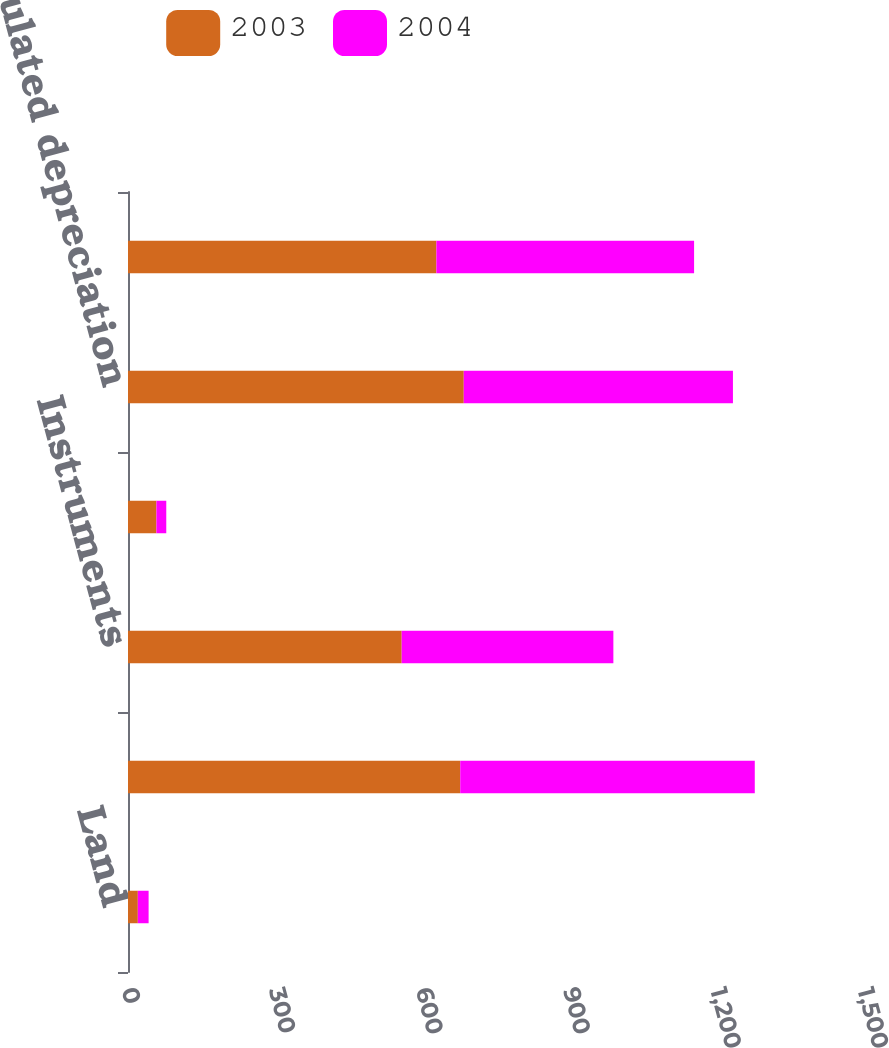Convert chart to OTSL. <chart><loc_0><loc_0><loc_500><loc_500><stacked_bar_chart><ecel><fcel>Land<fcel>Building and equipment<fcel>Instruments<fcel>Construction in progress<fcel>Accumulated depreciation<fcel>Property plant and equipment<nl><fcel>2003<fcel>20<fcel>677.1<fcel>557.8<fcel>57.9<fcel>684.3<fcel>628.5<nl><fcel>2004<fcel>22<fcel>600.3<fcel>431.4<fcel>20.1<fcel>548.6<fcel>525.2<nl></chart> 